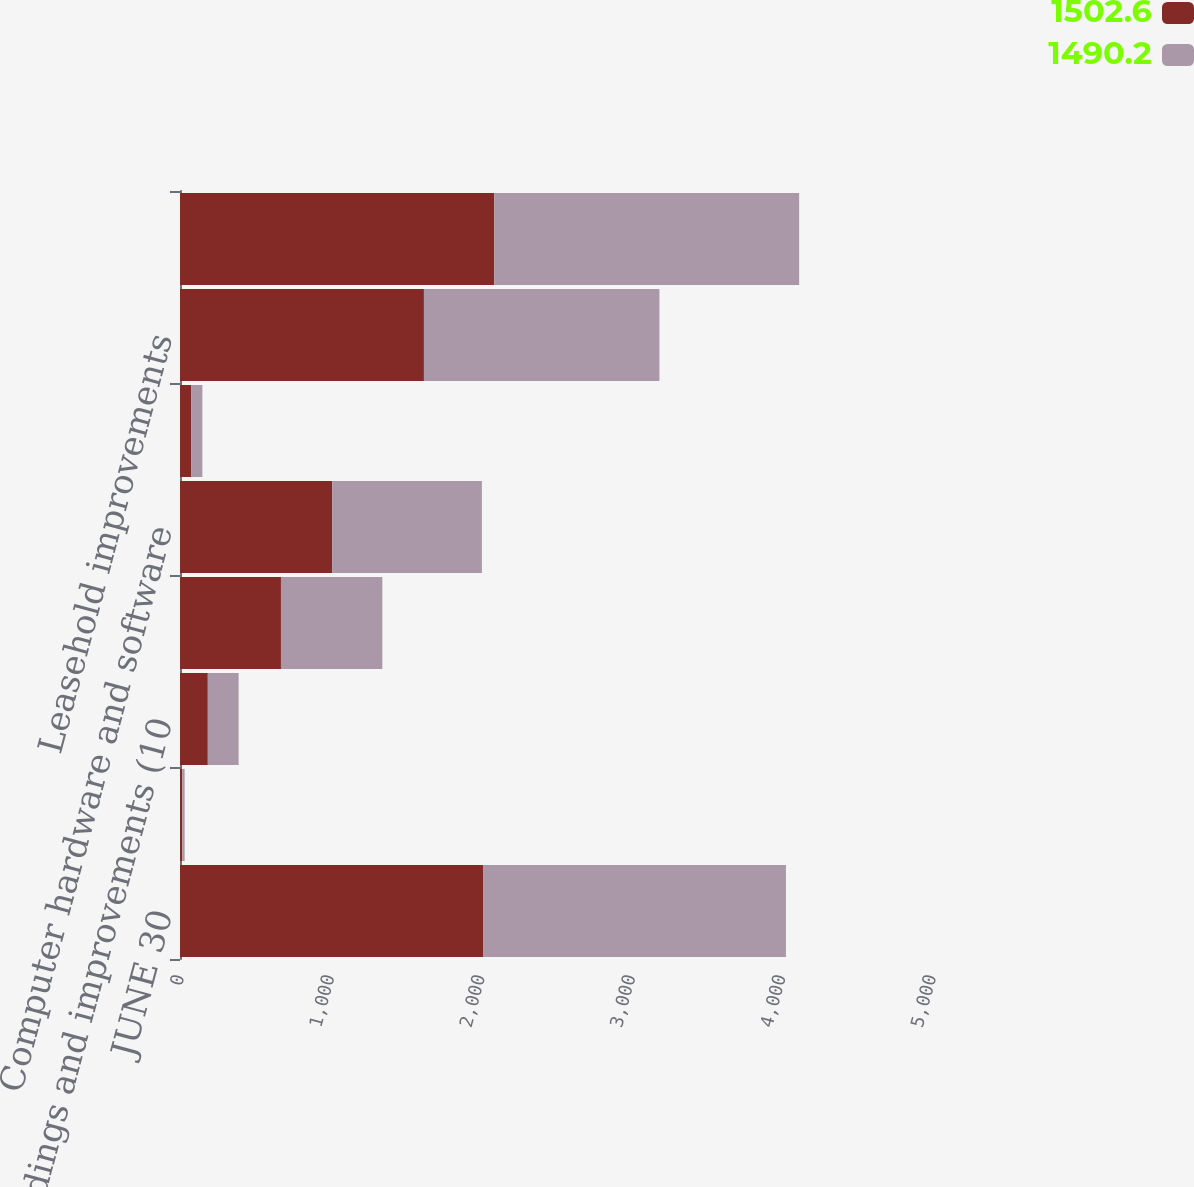Convert chart. <chart><loc_0><loc_0><loc_500><loc_500><stacked_bar_chart><ecel><fcel>JUNE 30<fcel>Land<fcel>Buildings and improvements (10<fcel>Machinery and equipment (3 to<fcel>Computer hardware and software<fcel>Furniture and fixtures (5 to<fcel>Leasehold improvements<fcel>Less accumulated depreciation<nl><fcel>1502.6<fcel>2015<fcel>15.4<fcel>184.9<fcel>671.3<fcel>1012.4<fcel>73.7<fcel>1621.9<fcel>2089.4<nl><fcel>1490.2<fcel>2014<fcel>15.4<fcel>205<fcel>673.9<fcel>994.8<fcel>75.1<fcel>1565.7<fcel>2027.3<nl></chart> 